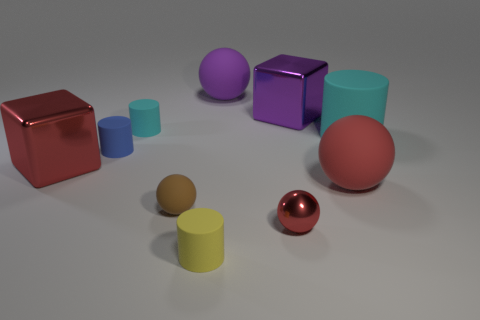What is the material of the tiny ball to the left of the rubber thing in front of the red ball that is to the left of the purple shiny thing?
Make the answer very short. Rubber. What number of other objects are the same size as the red matte sphere?
Ensure brevity in your answer.  4. There is a red object that is the same shape as the purple metal object; what is its material?
Offer a very short reply. Metal. The tiny metal object has what color?
Offer a very short reply. Red. What color is the metal object that is to the right of the tiny ball that is to the right of the large purple sphere?
Keep it short and to the point. Purple. Does the big cylinder have the same color as the rubber thing that is in front of the tiny brown matte object?
Keep it short and to the point. No. What number of tiny red metal balls are in front of the small cylinder in front of the cube on the left side of the tiny blue thing?
Your answer should be compact. 0. Are there any big cyan rubber cylinders left of the small blue cylinder?
Offer a very short reply. No. Are there any other things of the same color as the small metallic sphere?
Provide a short and direct response. Yes. What number of balls are either tiny things or purple matte things?
Your answer should be very brief. 3. 